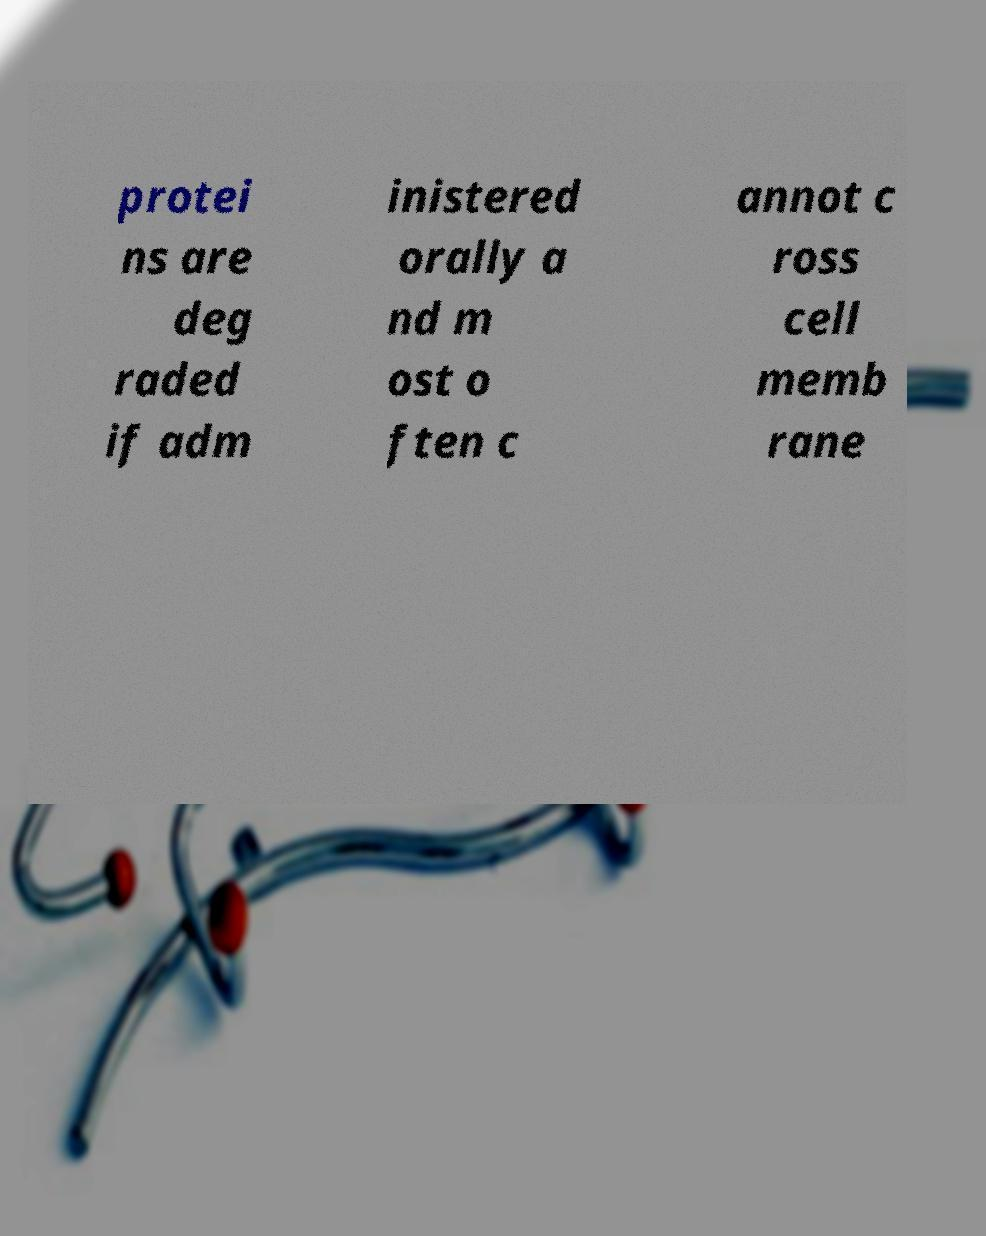Can you accurately transcribe the text from the provided image for me? protei ns are deg raded if adm inistered orally a nd m ost o ften c annot c ross cell memb rane 